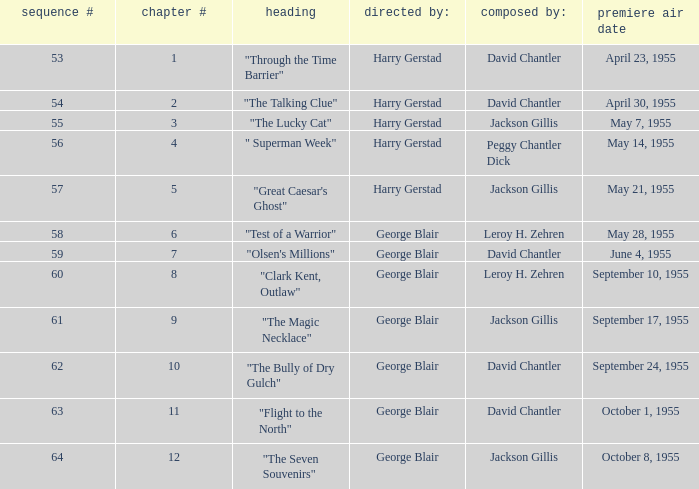When did season 9 originally air? September 17, 1955. 